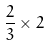<formula> <loc_0><loc_0><loc_500><loc_500>\frac { 2 } { 3 } \times 2</formula> 